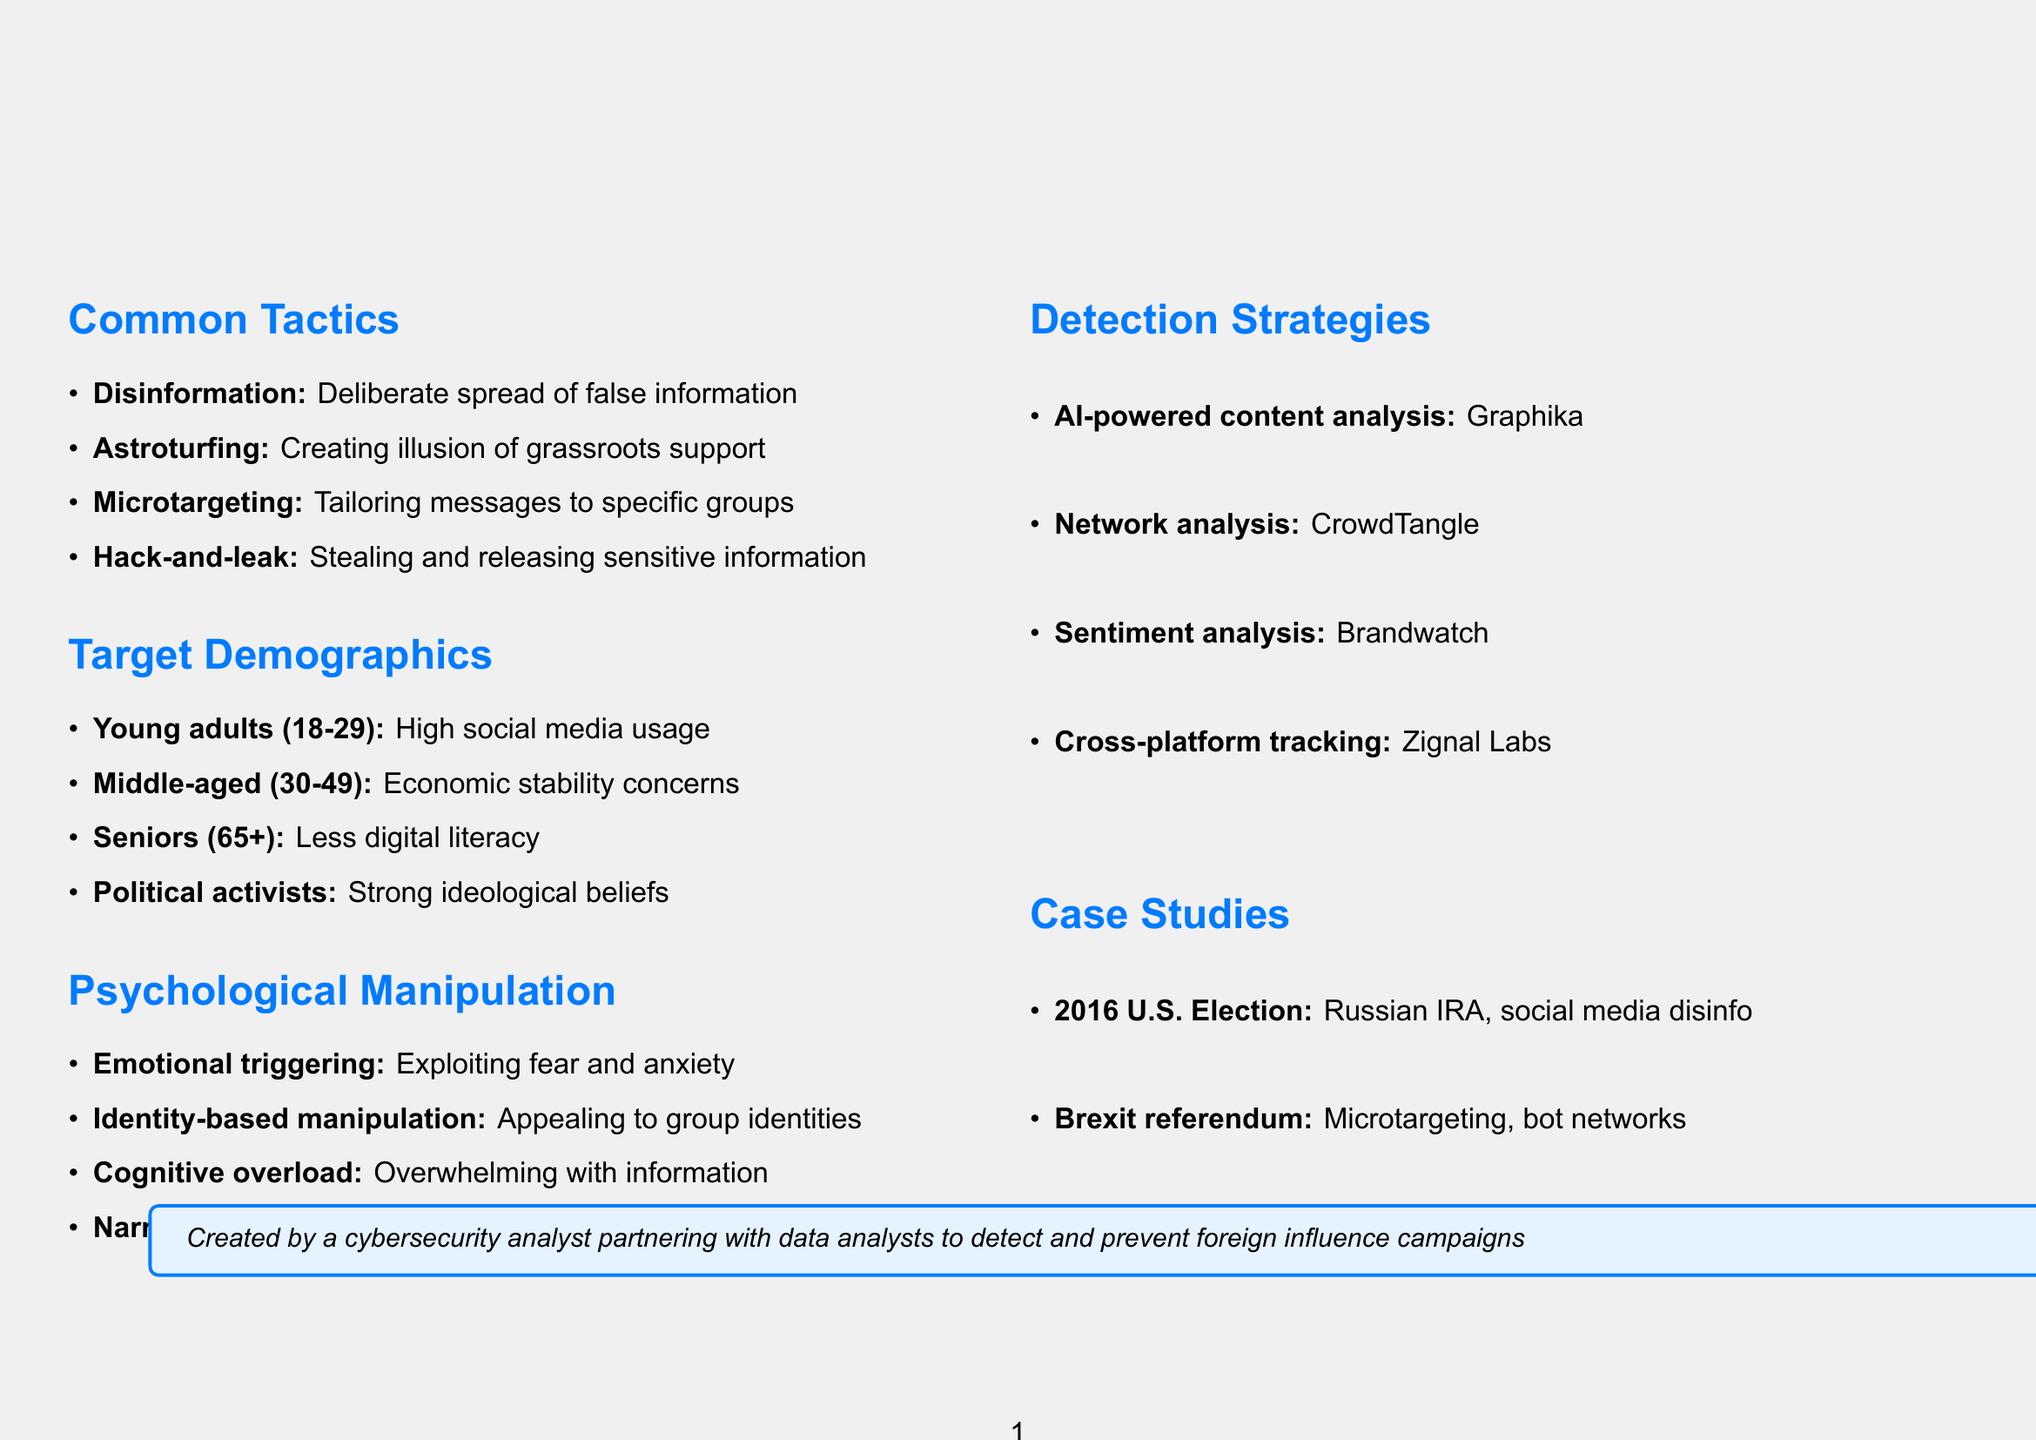what is the title of the document? The title is explicitly stated at the beginning of the document, showing what the brochure is about.
Answer: Foreign Influence Campaign Tactics: A Visual Guide name one common tactic used in foreign influence campaigns. The section on common tactics provides multiple examples, of which one can be selected.
Answer: Disinformation which demographic is most vulnerable due to high social media usage? The target demographics section identifies specific groups and their vulnerabilities.
Answer: Young adults (18-29) what psychological manipulation technique involves exploiting people's emotions? The section on psychological manipulation techniques defines specific strategies that relate to emotional engagement.
Answer: Emotional triggering how many detection strategies are listed in the document? The strategies for detection section outlines a specific number, which can be counted.
Answer: Four what is an example of a hack-and-leak operation mentioned in the document? The common tactics section gives a specific historical event as an example of hack-and-leak operations.
Answer: 2016 DNC email hack which platform is most commonly used by seniors according to the document? The target demographics section indicates which platforms are preferred by different age groups.
Answer: Facebook which tool is used for sentiment analysis in detection strategies? The detection strategies section specifies different tools along with their intended uses.
Answer: Brandwatch what was one tactic used in the Brexit referendum campaign? The case studies section provides examples of tactics employed in specific campaigns including the Brexit referendum.
Answer: Microtargeting on Facebook 